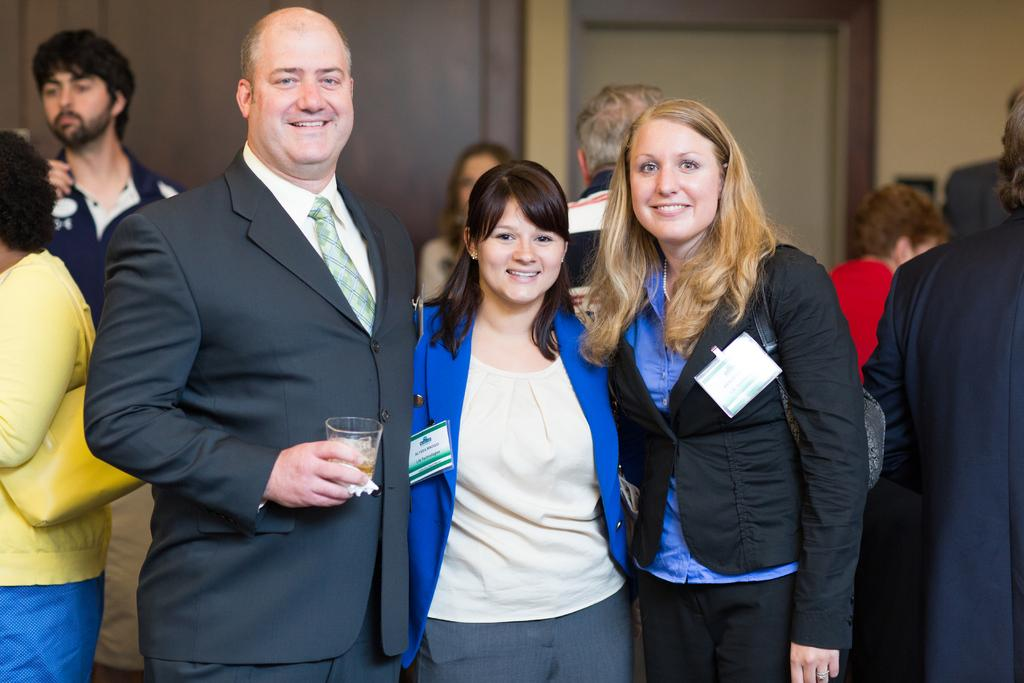How many people are present in the image? There are many people in the image. What are some people carrying in the image? Some people are wearing handbags. What is a person holding in his hand? A person is holding a drinking glass in his hand. Can you identify any architectural features in the image? Yes, there is a door in the image. How many ladybugs can be seen on the person holding the drinking glass? A: There are no ladybugs visible on the person holding the drinking glass in the image. What type of property does the vessel in the image represent? There is no vessel present in the image. 